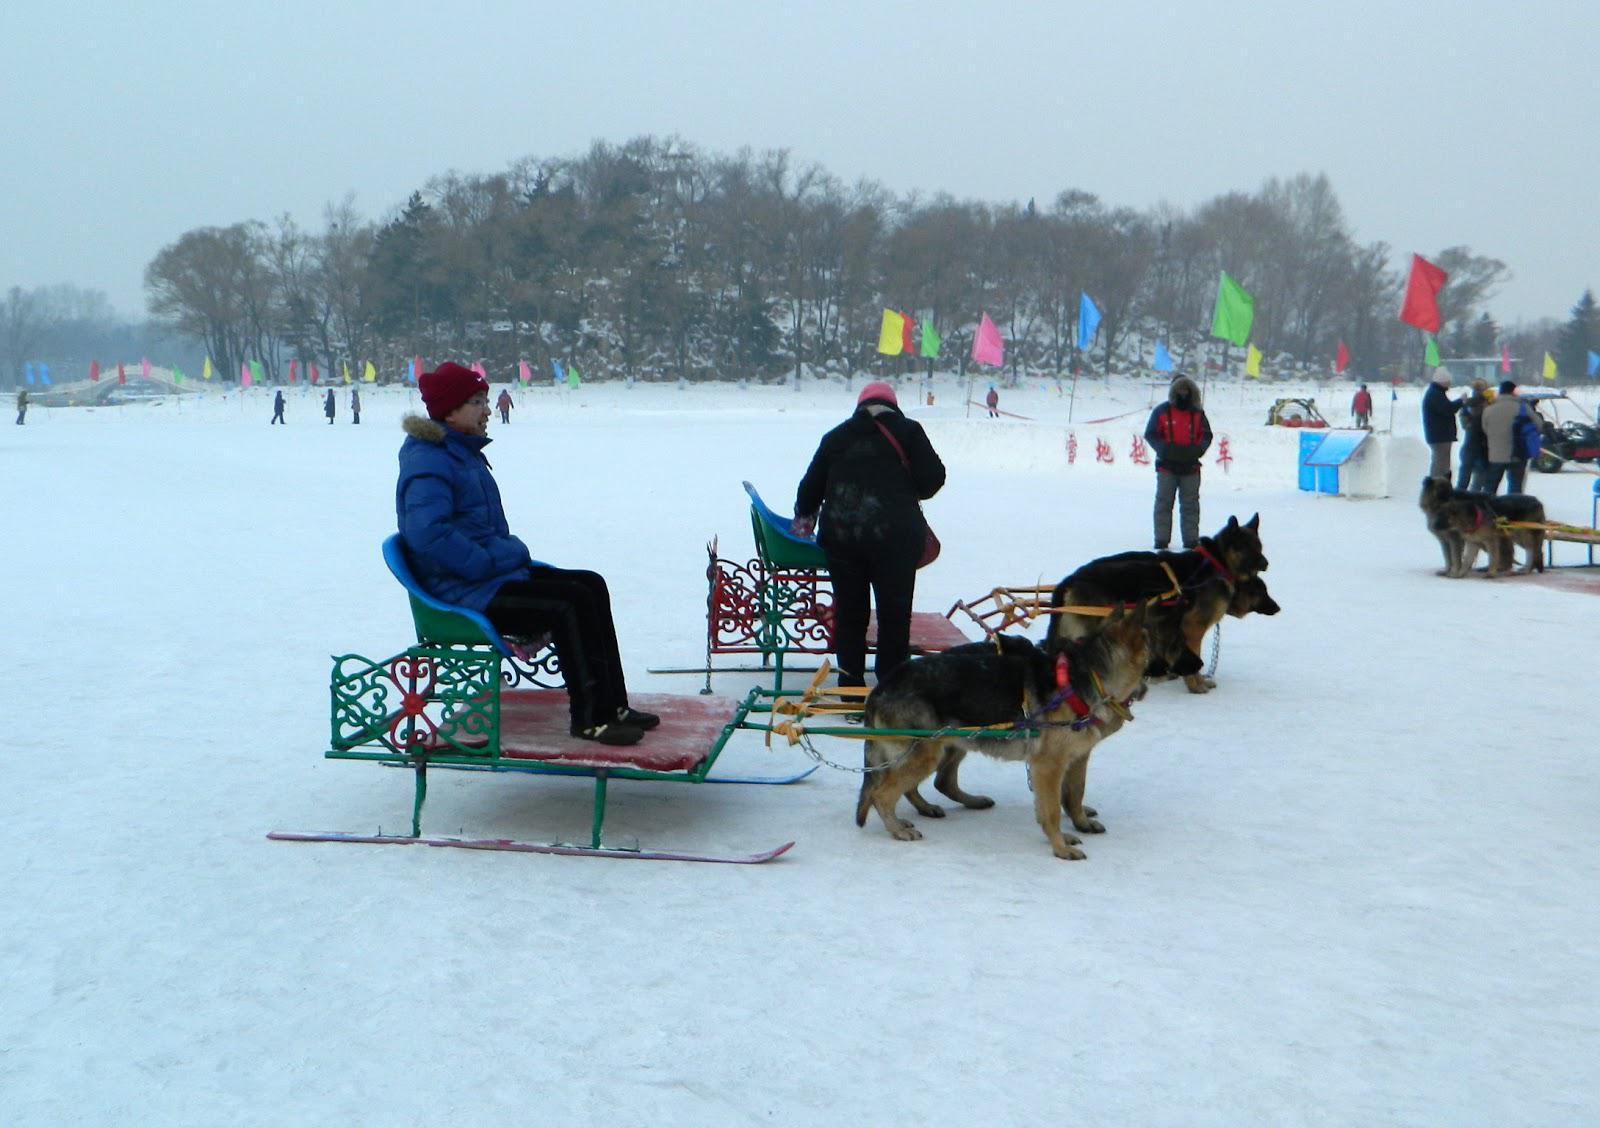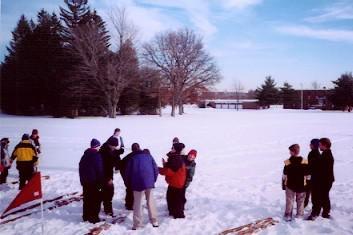The first image is the image on the left, the second image is the image on the right. Examine the images to the left and right. Is the description "In the left image, dogs are moving forward." accurate? Answer yes or no. No. 